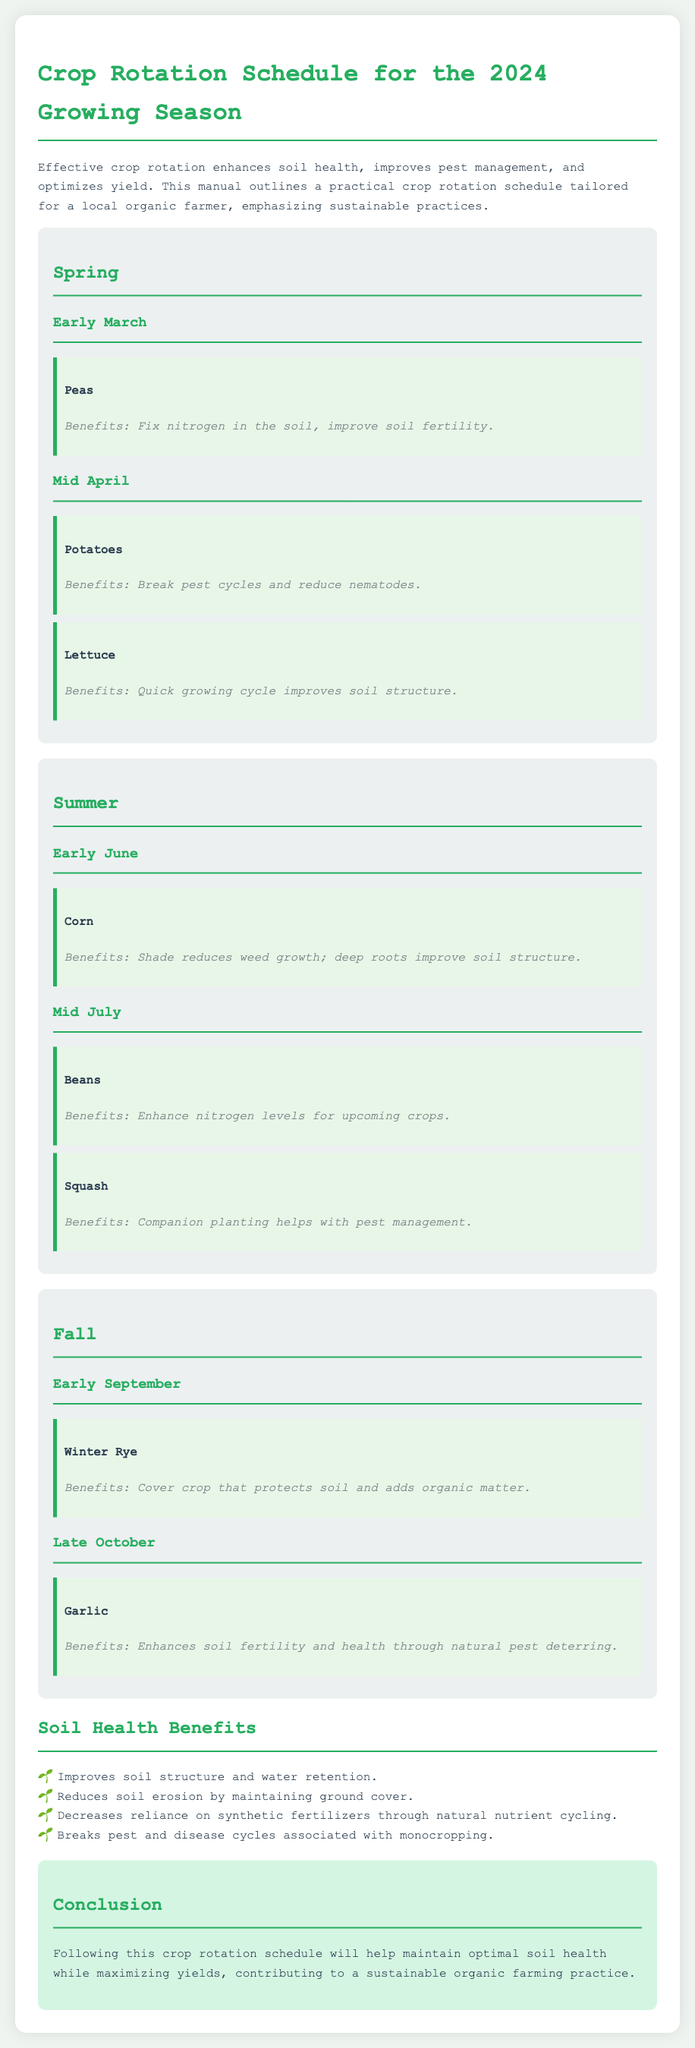What is the first crop to be planted in Spring? The first crop mentioned for planting in Spring is Peas, to be planted in Early March.
Answer: Peas What benefits do potatoes provide when planted? The benefits of planting potatoes, which are planted in Mid April, include breaking pest cycles and reducing nematodes.
Answer: Break pest cycles and reduce nematodes When are corn crops scheduled for planting? Corn crops are scheduled to be planted in Early June during the Summer season.
Answer: Early June List one benefit of planting Winter Rye. Winter Rye, planted in Early September, serves as a cover crop that protects soil and adds organic matter.
Answer: Protects soil and adds organic matter How does planting beans benefit the soil? Beans, which are planted in Mid July, enhance nitrogen levels for upcoming crops, benefiting soil fertility.
Answer: Enhance nitrogen levels What month is garlic planted? Garlic is scheduled to be planted in Late October during the Fall season.
Answer: Late October What are two benefits of following the crop rotation schedule? The document states that following the crop rotation schedule will help maintain optimal soil health while maximizing yields, contributing to sustainable practices.
Answer: Optimal soil health and maximizing yields How does soil health improve according to the document? Soil health improves by reducing reliance on synthetic fertilizers and maintaining ground cover to decrease erosion.
Answer: Reduces reliance on synthetic fertilizers What is the purpose of the crop rotation schedule? The general purpose of the crop rotation schedule is to enhance soil health, improve pest management, and optimize yield for sustainable farming.
Answer: Enhance soil health 